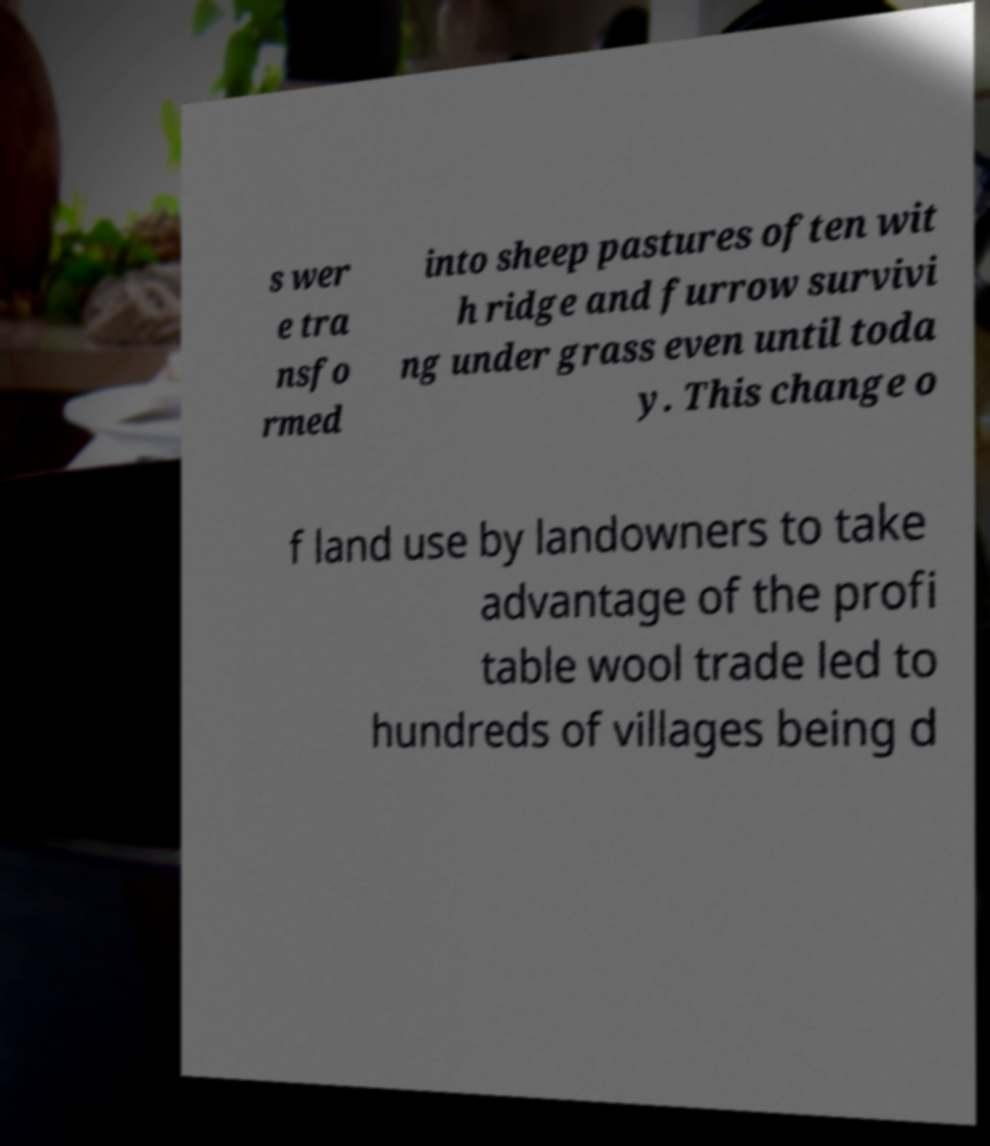Please identify and transcribe the text found in this image. s wer e tra nsfo rmed into sheep pastures often wit h ridge and furrow survivi ng under grass even until toda y. This change o f land use by landowners to take advantage of the profi table wool trade led to hundreds of villages being d 